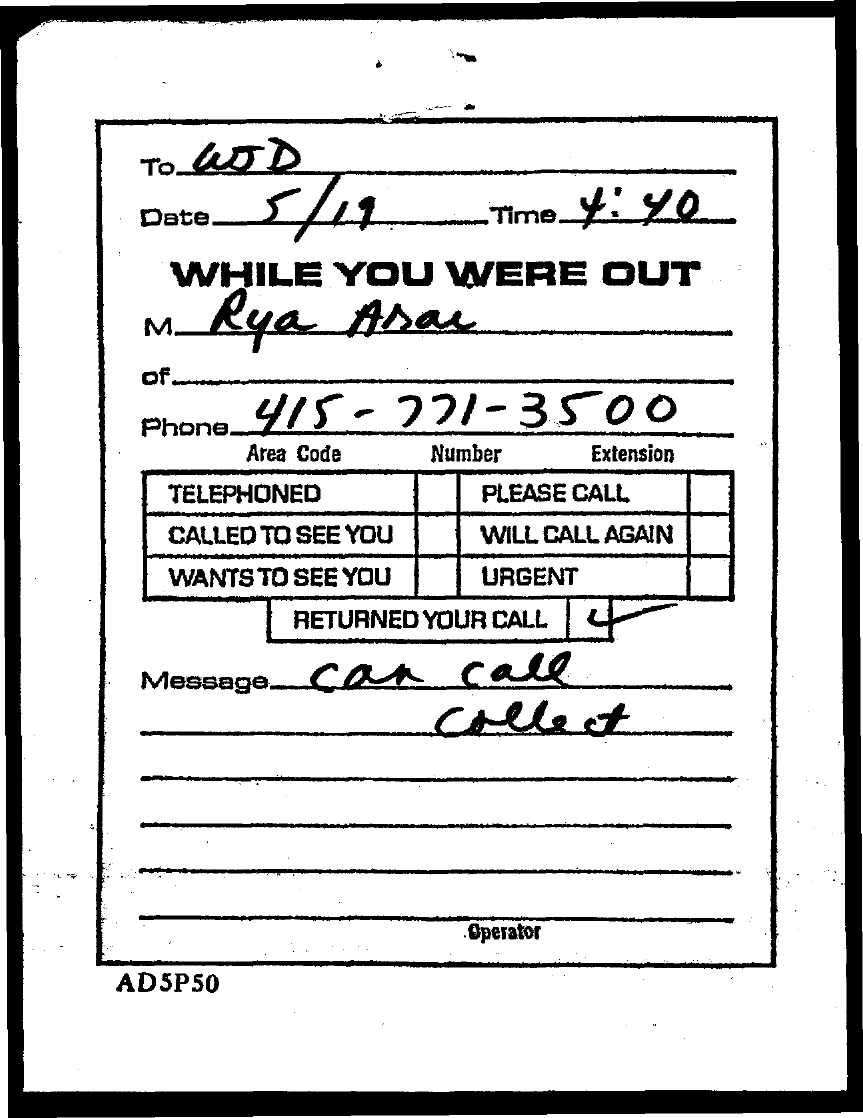Highlight a few significant elements in this photo. The document contains a date that is mentioned as 5/19. The area code is 415.. The time mentioned in the document is 4:40. 